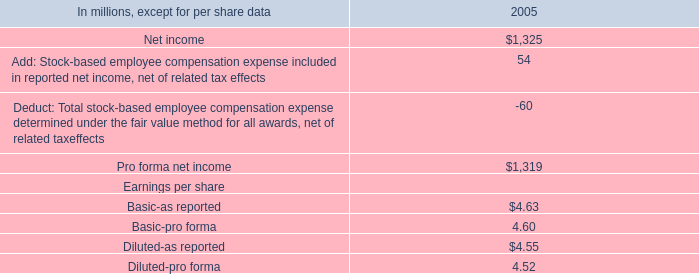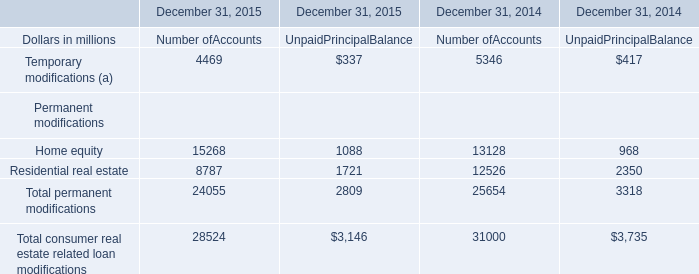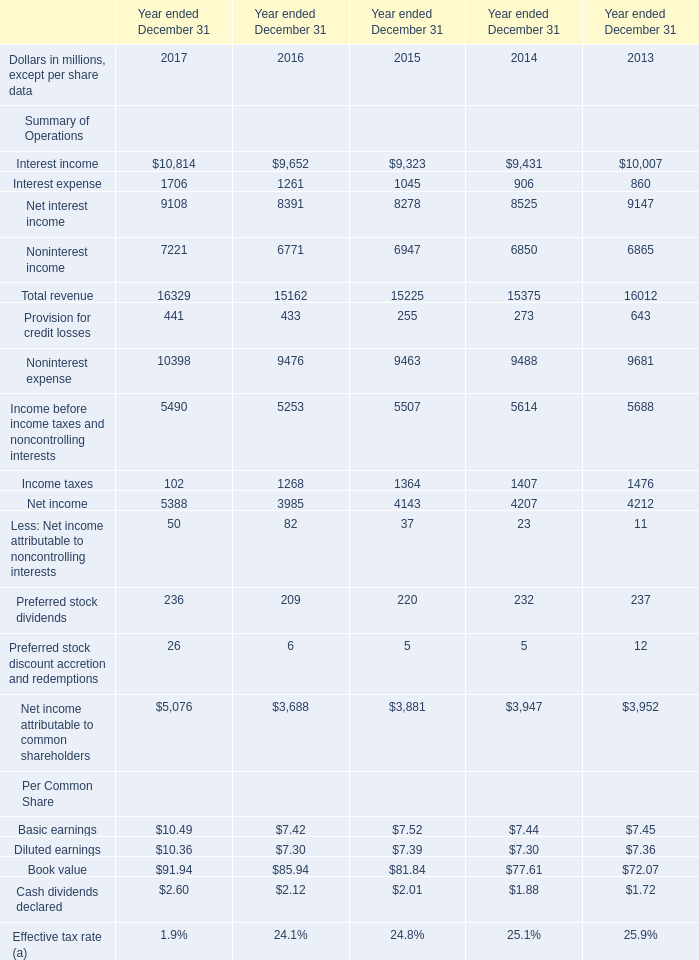What is the ratio of Total revenue in Table 2 to the Total permanent modifications of Number of Accounts in Table 1 in 2015? 
Computations: (15225 / 24055)
Answer: 0.63292. 